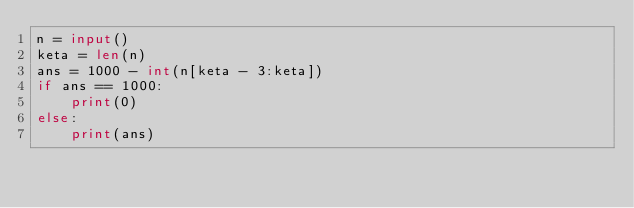Convert code to text. <code><loc_0><loc_0><loc_500><loc_500><_Python_>n = input()
keta = len(n)
ans = 1000 - int(n[keta - 3:keta])
if ans == 1000:
	print(0)
else:
	print(ans)
</code> 